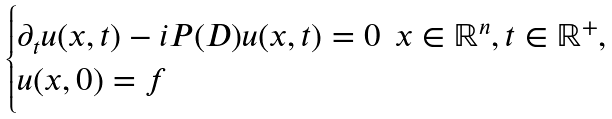<formula> <loc_0><loc_0><loc_500><loc_500>\begin{cases} \partial _ { t } u ( x , t ) - i P ( D ) u ( x , t ) = 0 \, \ x \in \mathbb { R } ^ { n } , t \in \mathbb { R } ^ { + } , \\ u ( x , 0 ) = f \\ \end{cases}</formula> 